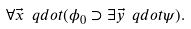Convert formula to latex. <formula><loc_0><loc_0><loc_500><loc_500>\forall \vec { x } \ q d o t ( \phi _ { 0 } \supset \exists \vec { y } \ q d o t \psi ) .</formula> 